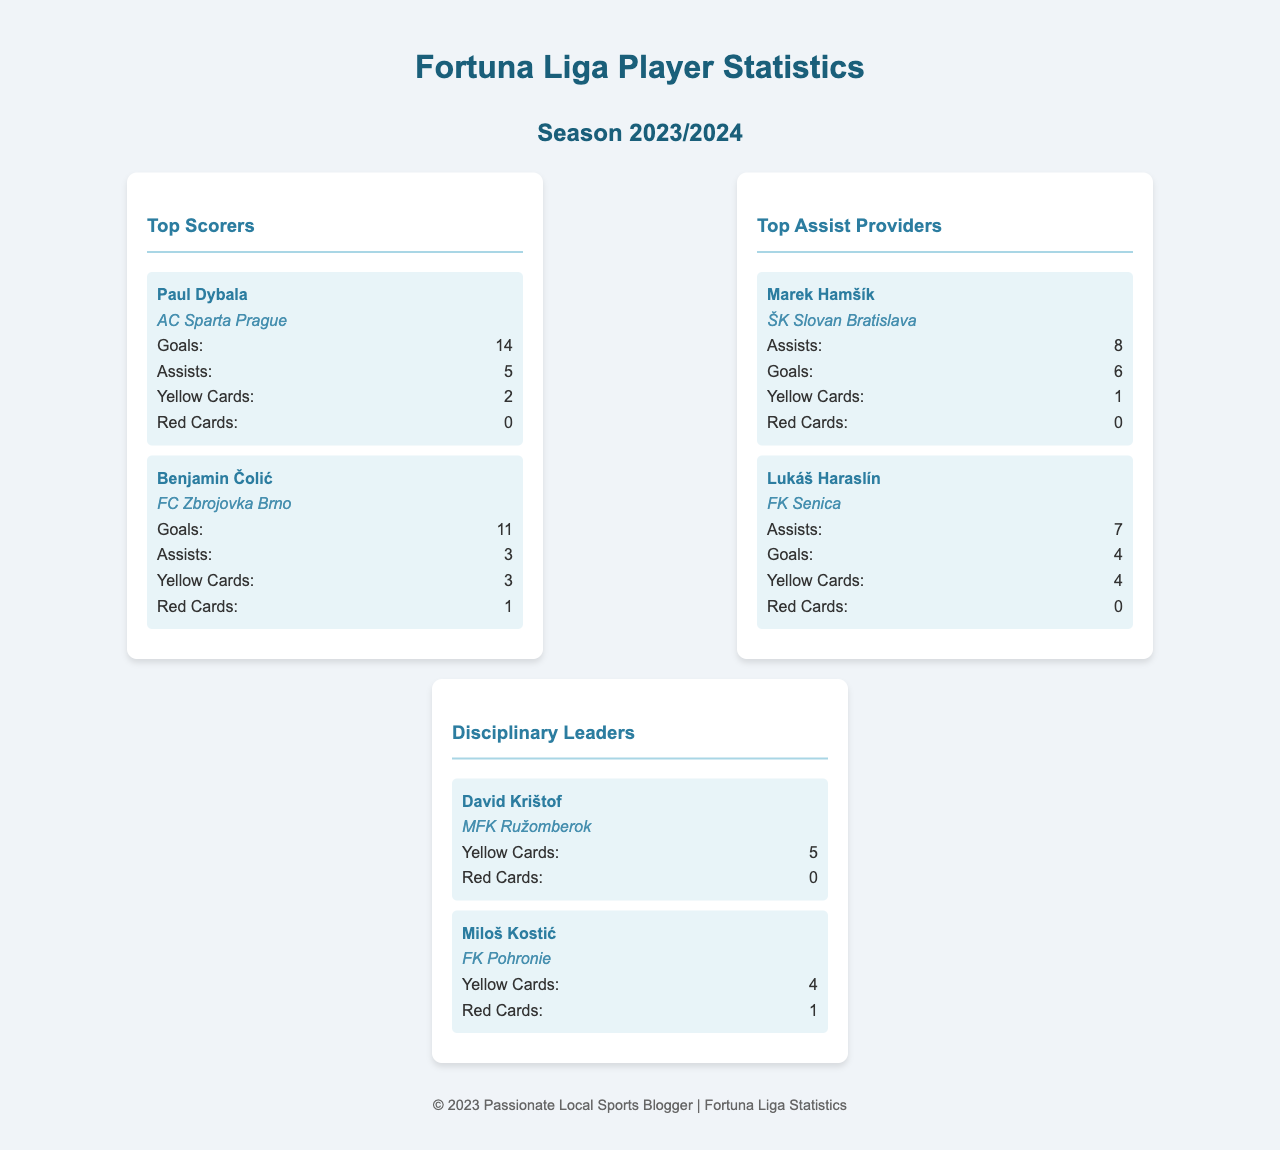What is the total number of goals scored by Paul Dybala? Paul Dybala's goals are listed under the Top Scorers section, where he scored 14 goals.
Answer: 14 Who is the player with the highest number of assists? The player with the highest number of assists is Marek Hamšík, as shown in the Top Assist Providers section with 8 assists.
Answer: Marek Hamšík How many yellow cards has David Krištof received? The disciplinary record for David Krištof indicates he has received 5 yellow cards.
Answer: 5 Which club does Benjamin Čolić play for? The club associated with Benjamin Čolić is mentioned in the Top Scorers section, where he plays for FC Zbrojovka Brno.
Answer: FC Zbrojovka Brno What is the total number of red cards received by Miloš Kostić? The disciplinary record for Miloš Kostić shows he has received 1 red card.
Answer: 1 Who is the top scorer from AC Sparta Prague? The top scorer from AC Sparta Prague is noted, and that player is Paul Dybala, who leads with 14 goals.
Answer: Paul Dybala How many assists does Lukáš Haraslín have? Under the Top Assist Providers section, Lukáš Haraslín has been credited with 7 assists.
Answer: 7 Which player has the most disciplinary issues? The player with the most yellow cards is David Krištof, who has 5 yellow cards.
Answer: David Krištof What is the total number of players listed in the Top Scorers section? The Top Scorers section lists 2 players, Paul Dybala and Benjamin Čolić.
Answer: 2 